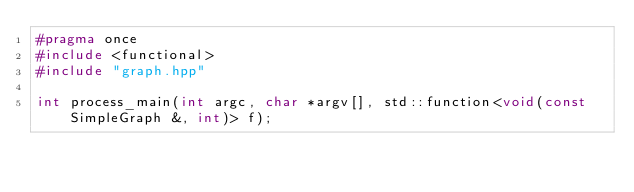<code> <loc_0><loc_0><loc_500><loc_500><_C++_>#pragma once
#include <functional>
#include "graph.hpp"

int process_main(int argc, char *argv[], std::function<void(const SimpleGraph &, int)> f);
</code> 